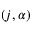Convert formula to latex. <formula><loc_0><loc_0><loc_500><loc_500>( j , \alpha )</formula> 